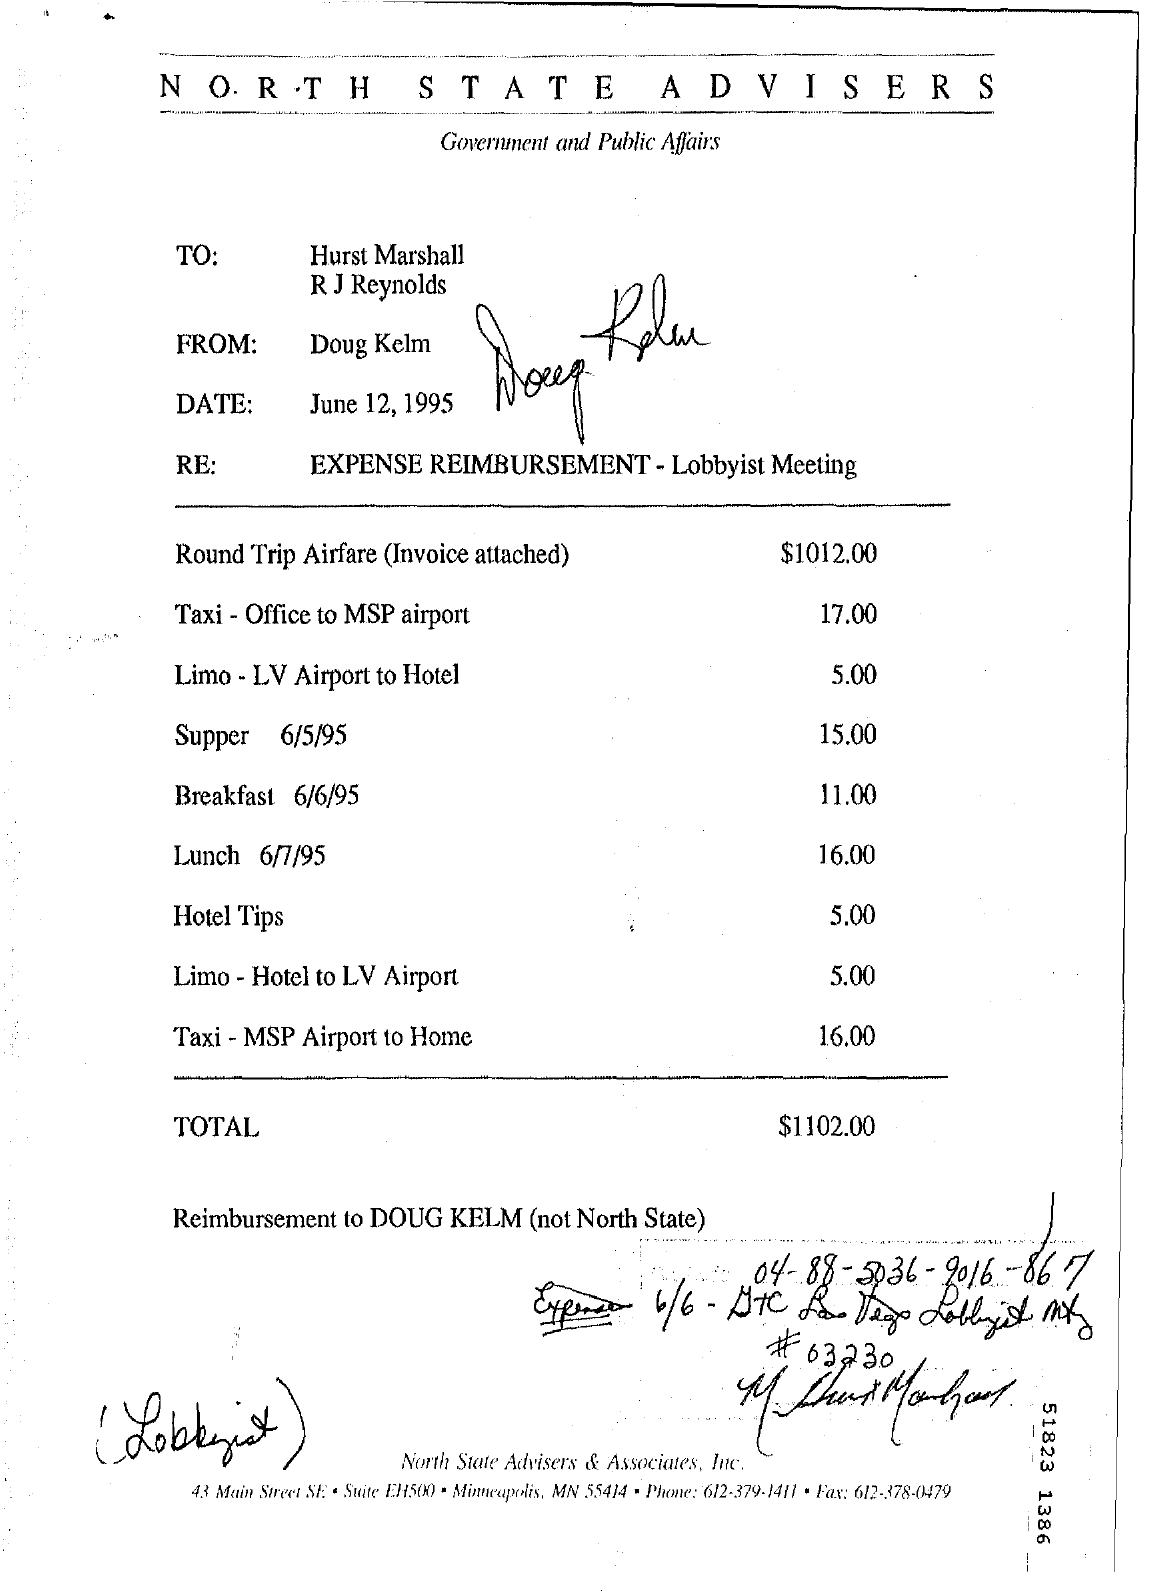Indicate a few pertinent items in this graphic. The memorandum is dated June 12, 1995. On June 6th, 1995, there was a breakfast date. On June 7th, 1995, there was a lunch date. The memorandum is from Doug Kelm. 